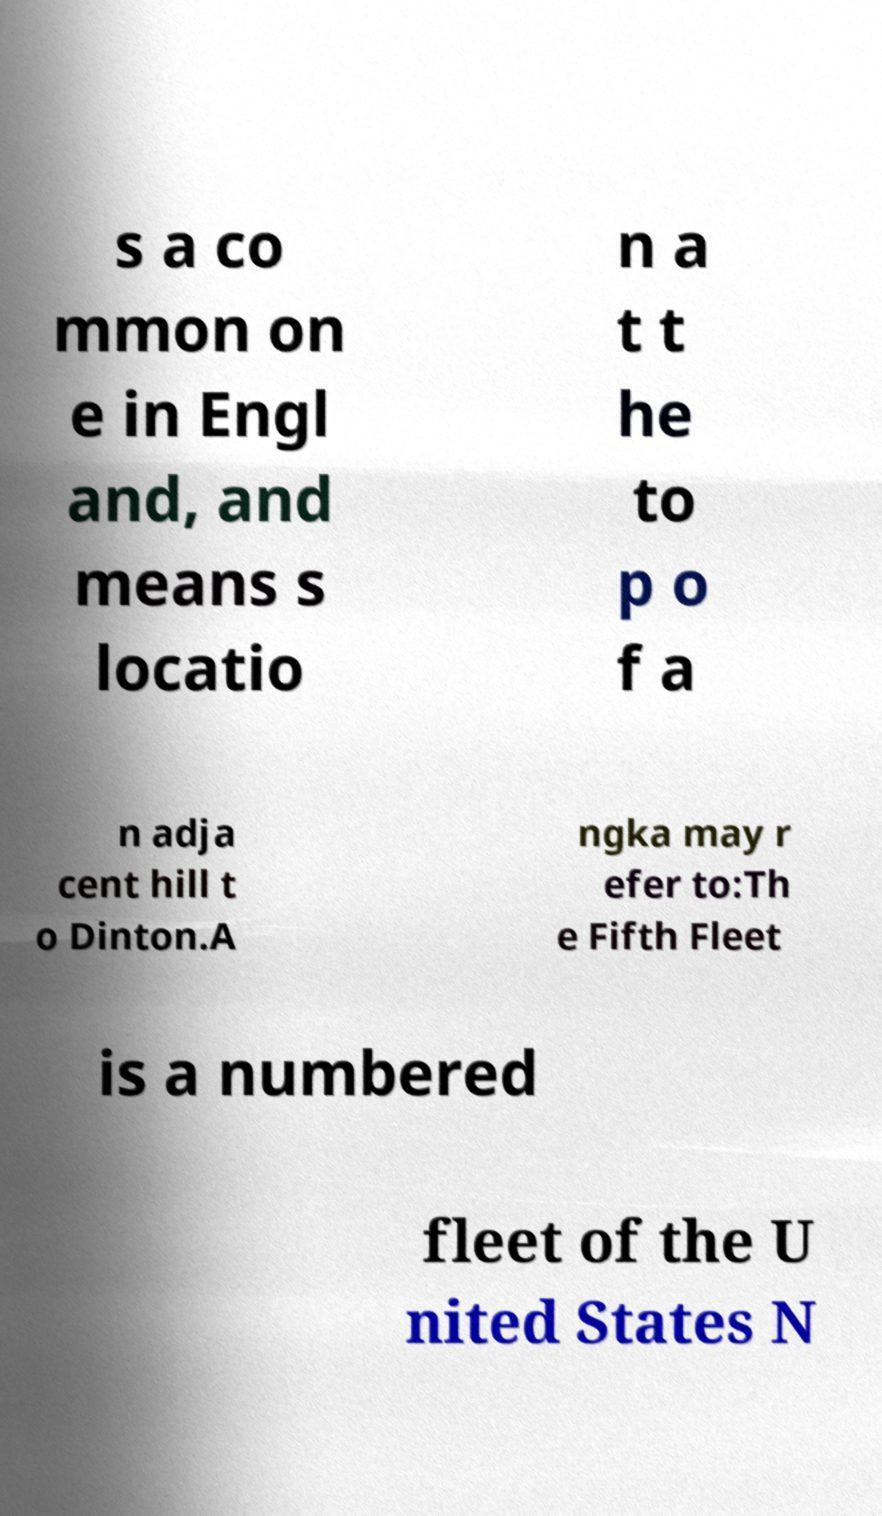Please identify and transcribe the text found in this image. s a co mmon on e in Engl and, and means s locatio n a t t he to p o f a n adja cent hill t o Dinton.A ngka may r efer to:Th e Fifth Fleet is a numbered fleet of the U nited States N 